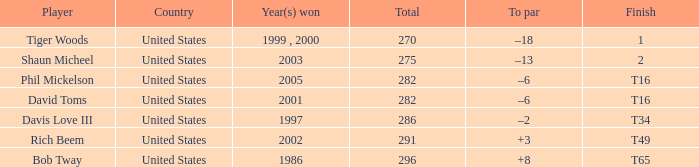What is the total sum for davis love iii? 286.0. 